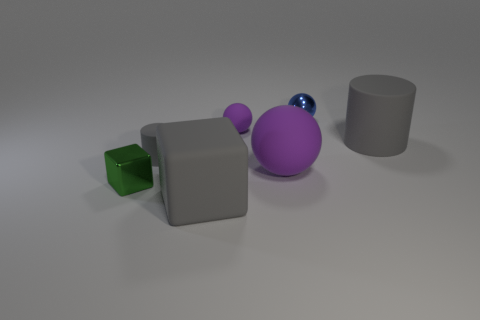Add 1 big green matte cubes. How many objects exist? 8 Subtract all spheres. How many objects are left? 4 Add 3 small matte balls. How many small matte balls exist? 4 Subtract 0 red cylinders. How many objects are left? 7 Subtract all matte blocks. Subtract all matte cylinders. How many objects are left? 4 Add 3 gray rubber objects. How many gray rubber objects are left? 6 